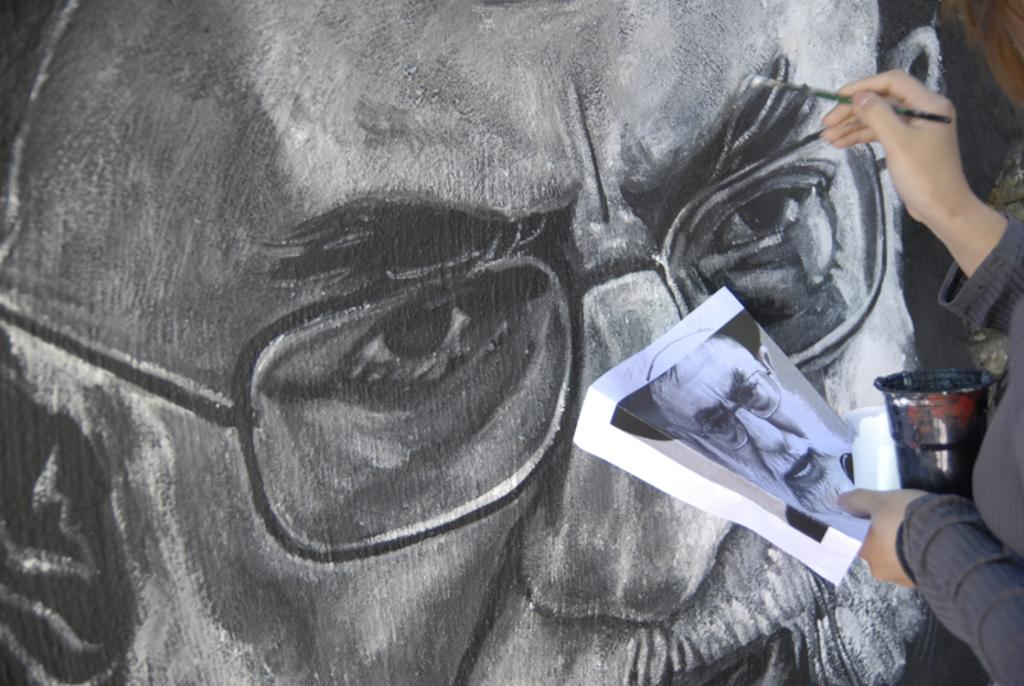Who is present in the image? There is a person in the image. What is the person holding? The person is holding a paper. What object related to art can be seen in the image? There is a paint box in the image. What is the paint box being used for? The paint box is being used to paint on a wall. What type of image is visible in the picture? There is a picture of a man in the image. What type of star can be seen in the image? There is no star present in the image. Where is the office located in the image? There is no office present in the image. 